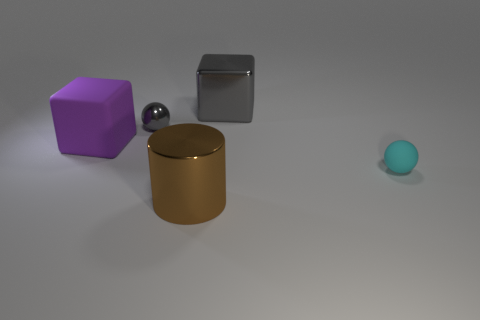Subtract 2 blocks. How many blocks are left? 0 Add 2 cyan matte spheres. How many objects exist? 7 Subtract all cylinders. How many objects are left? 4 Subtract 1 gray spheres. How many objects are left? 4 Subtract all blue cylinders. Subtract all gray balls. How many cylinders are left? 1 Subtract all big gray metallic things. Subtract all gray shiny blocks. How many objects are left? 3 Add 3 small things. How many small things are left? 5 Add 3 blue things. How many blue things exist? 3 